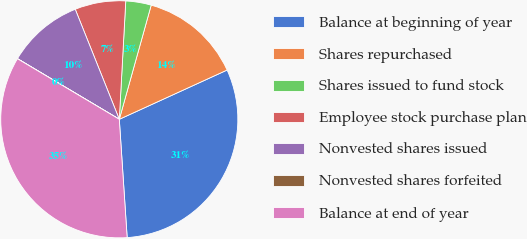<chart> <loc_0><loc_0><loc_500><loc_500><pie_chart><fcel>Balance at beginning of year<fcel>Shares repurchased<fcel>Shares issued to fund stock<fcel>Employee stock purchase plan<fcel>Nonvested shares issued<fcel>Nonvested shares forfeited<fcel>Balance at end of year<nl><fcel>30.77%<fcel>13.84%<fcel>3.47%<fcel>6.93%<fcel>10.39%<fcel>0.01%<fcel>34.6%<nl></chart> 